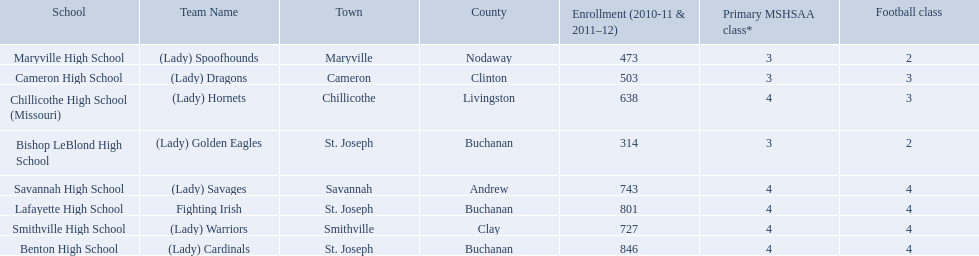What are the three schools in the town of st. joseph? St. Joseph, St. Joseph, St. Joseph. Of the three schools in st. joseph which school's team name does not depict a type of animal? Lafayette High School. What team uses green and grey as colors? Fighting Irish. What is this team called? Lafayette High School. 